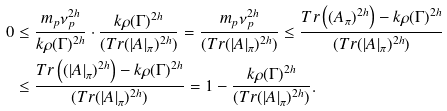<formula> <loc_0><loc_0><loc_500><loc_500>0 & \leq \frac { m _ { p } \nu _ { p } ^ { 2 h } } { k \rho ( \Gamma ) ^ { 2 h } } \cdot \frac { k \rho ( \Gamma ) ^ { 2 h } } { ( T r ( | A | _ { \pi } ) ^ { 2 h } ) } = \frac { m _ { p } \nu _ { p } ^ { 2 h } } { ( T r ( | A | _ { \pi } ) ^ { 2 h } ) } \leq \frac { T r \left ( ( A _ { \pi } ) ^ { 2 h } \right ) - k \rho ( \Gamma ) ^ { 2 h } } { ( T r ( | A | _ { \pi } ) ^ { 2 h } ) } \\ & \leq \frac { T r \left ( ( | A | _ { \pi } ) ^ { 2 h } \right ) - k \rho ( \Gamma ) ^ { 2 h } } { ( T r ( | A | _ { \pi } ) ^ { 2 h } ) } = 1 - \frac { k \rho ( \Gamma ) ^ { 2 h } } { ( T r ( | A | _ { \pi } ) ^ { 2 h } ) } .</formula> 